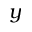Convert formula to latex. <formula><loc_0><loc_0><loc_500><loc_500>y</formula> 